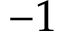<formula> <loc_0><loc_0><loc_500><loc_500>- 1</formula> 